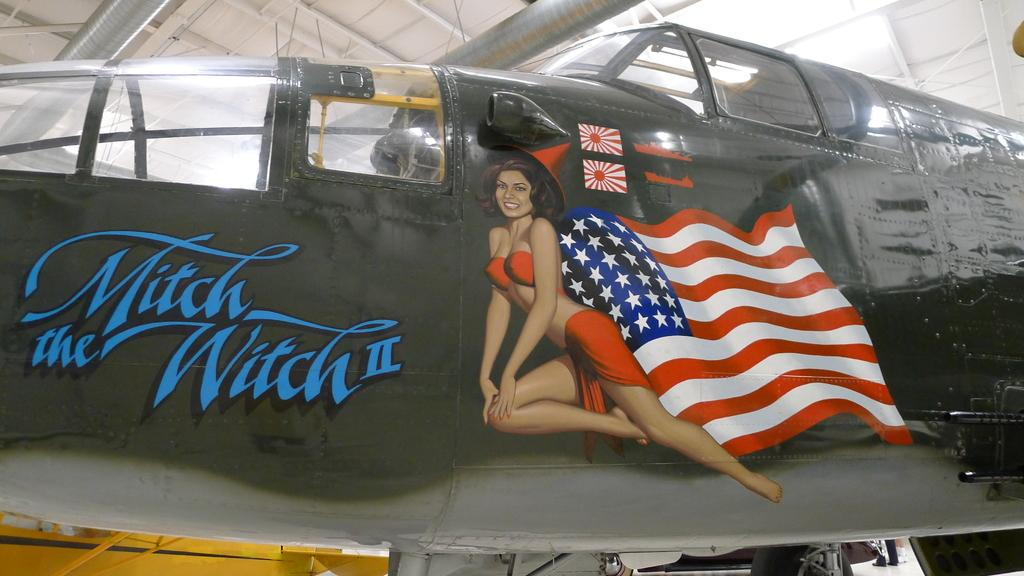<image>
Give a short and clear explanation of the subsequent image. Black helicotper with Mitch the Witch II in blue and a girl in front of an american flag. 